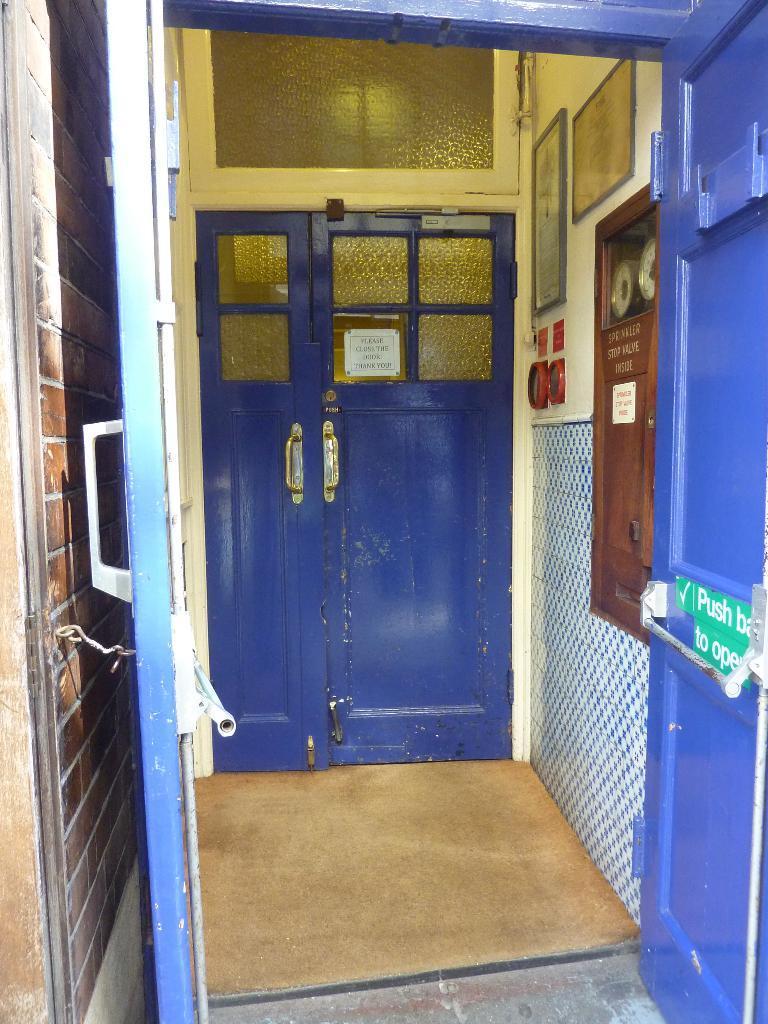In one or two sentences, can you explain what this image depicts? In this image I can see blue color doors and wall. On the wall I can see some objects. 